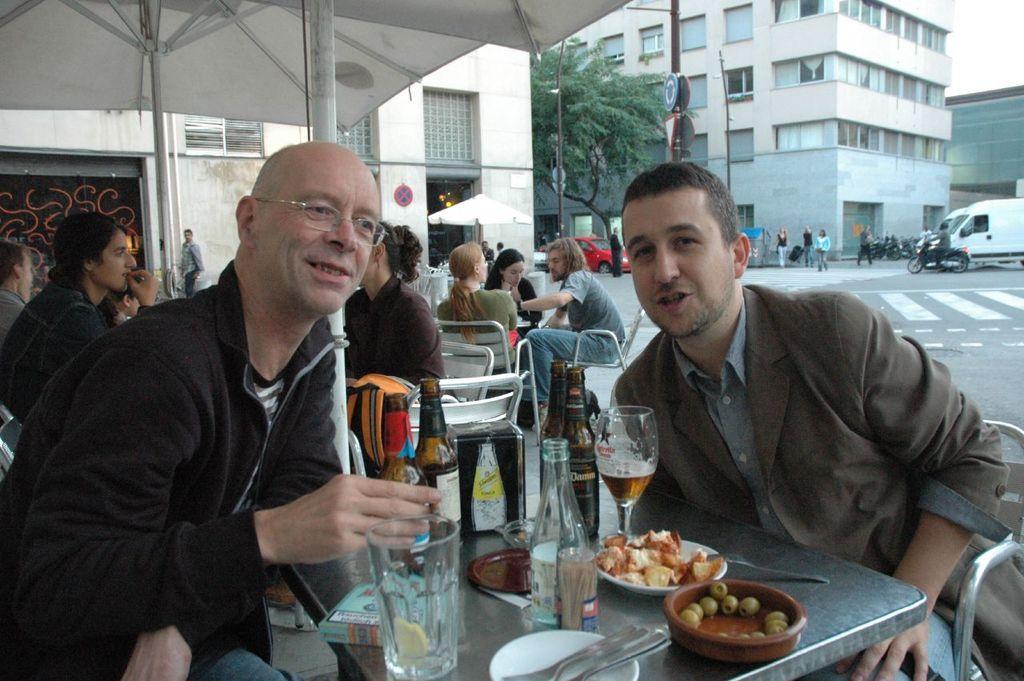In one or two sentences, can you explain what this image depicts? In this image, there are some persons sitting in chairs and wearing colorful clothes. There is a table in front of these persons. This table contains bottles, glasses, plates and spoons. There are three buildings behind these persons. There are vehicles behind this person. There is an umbrella in the top left. There is tree at the top of the image. 